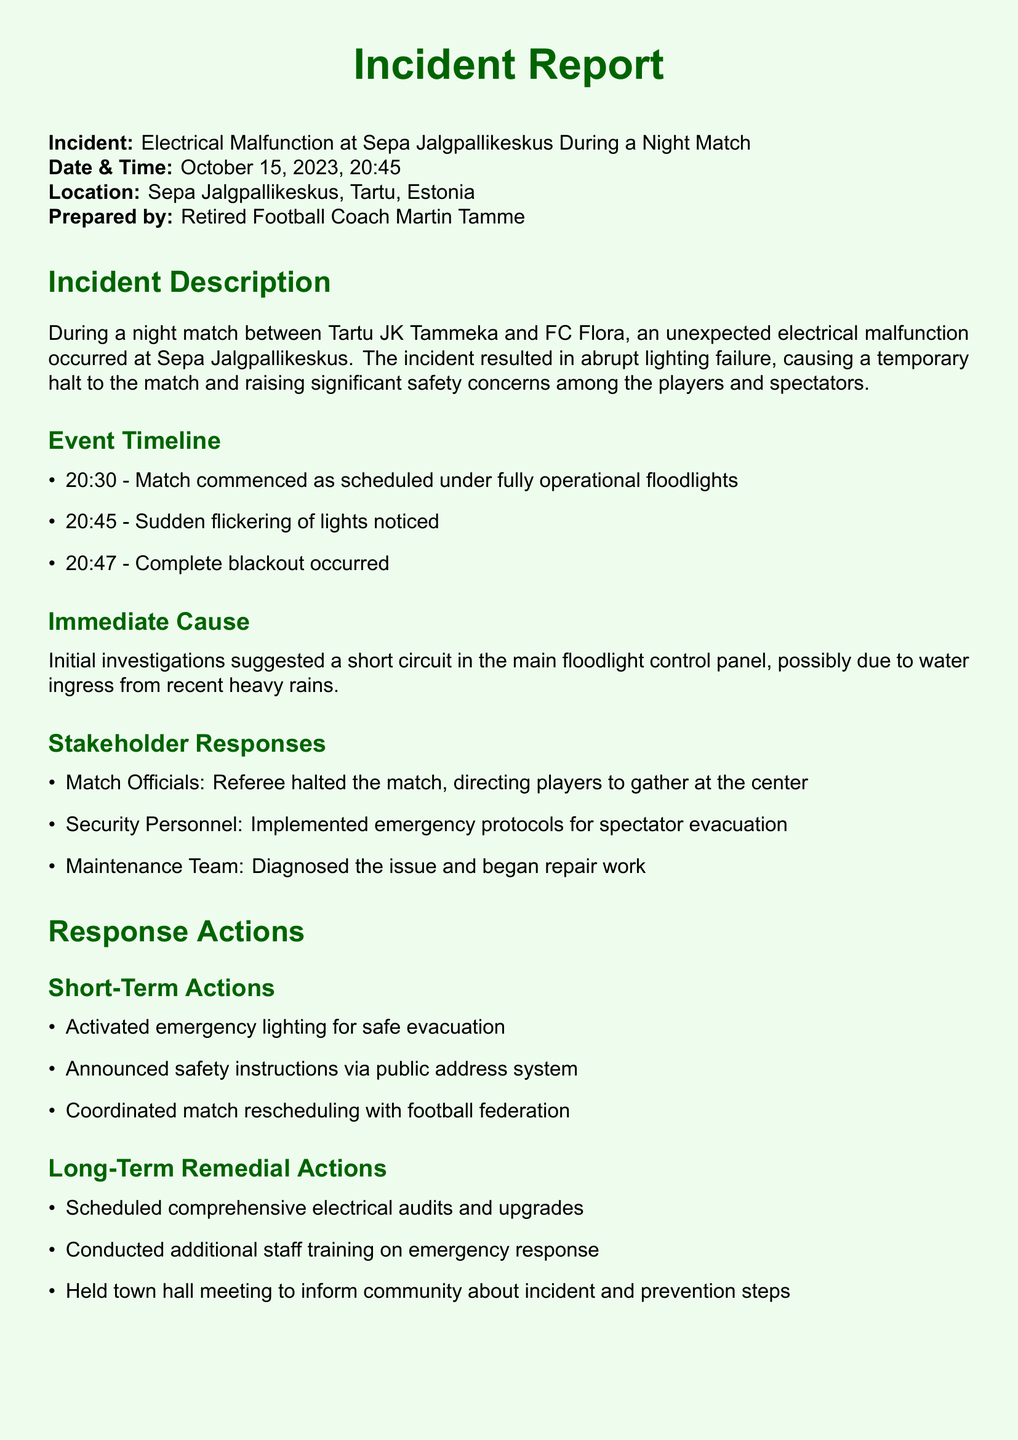what time did the electrical malfunction occur? The electrical malfunction occurred at 20:45 on October 15, 2023.
Answer: 20:45 what was the initial cause of the electrical malfunction? The initial cause was suggested to be a short circuit in the main floodlight control panel.
Answer: short circuit which teams were playing during the incident? The match was between Tartu JK Tammeka and FC Flora.
Answer: Tartu JK Tammeka and FC Flora how many minutes after the match started did the blackout occur? The blackout occurred 17 minutes after the match began at 20:30.
Answer: 17 minutes what emergency safety action was taken for spectator evacuation? Security personnel implemented emergency protocols for spectator evacuation.
Answer: emergency protocols what type of meeting was held to inform the community? A town hall meeting was held to inform the community about the incident and prevention steps.
Answer: town hall meeting how many response actions were identified in the short-term actions? There were three short-term actions identified in the report.
Answer: three who prepared this incident report? The incident report was prepared by Retired Football Coach Martin Tamme.
Answer: Martin Tamme 